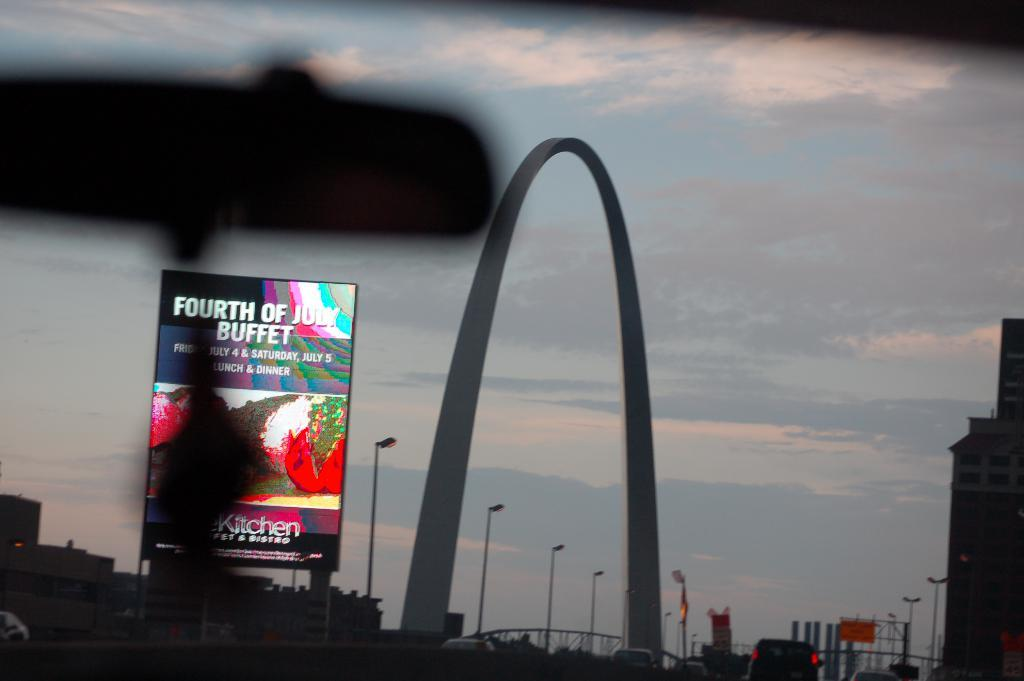<image>
Offer a succinct explanation of the picture presented. The advertising on the billboard shows that there is a buffet being served on the fourth of July. 